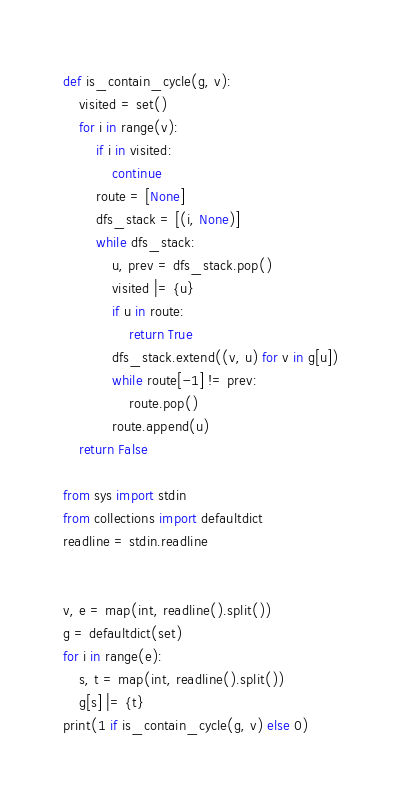<code> <loc_0><loc_0><loc_500><loc_500><_Python_>def is_contain_cycle(g, v):
    visited = set()
    for i in range(v):
        if i in visited:
            continue
        route = [None]
        dfs_stack = [(i, None)]            
        while dfs_stack:
            u, prev = dfs_stack.pop()
            visited |= {u}
            if u in route:
                return True
            dfs_stack.extend((v, u) for v in g[u])
            while route[-1] != prev:
                route.pop()
            route.append(u)
    return False

from sys import stdin
from collections import defaultdict
readline = stdin.readline


v, e = map(int, readline().split())
g = defaultdict(set)
for i in range(e):
    s, t = map(int, readline().split())
    g[s] |= {t}
print(1 if is_contain_cycle(g, v) else 0)</code> 